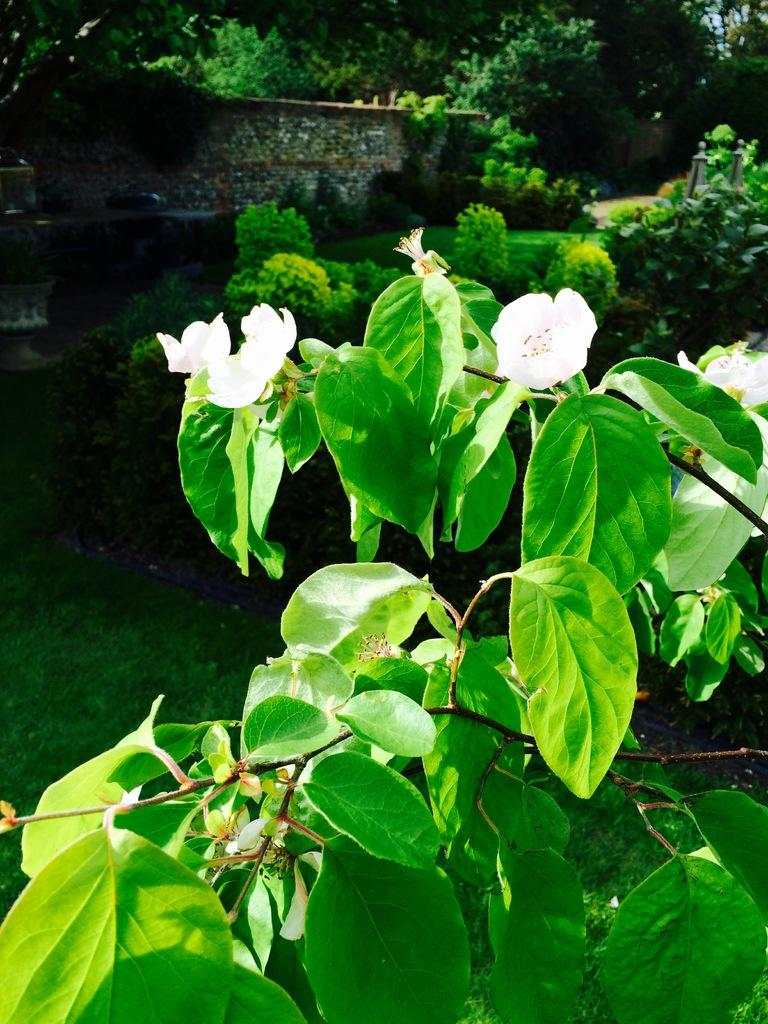What type of plant is featured in the image? There is a plant with white flowers in the image. What else can be seen in the background of the image? There are plants, a wall, and trees in the background of the image. What type of attention is the plant receiving at the hospital in the image? There is no hospital present in the image, and the plant is not receiving any attention. 